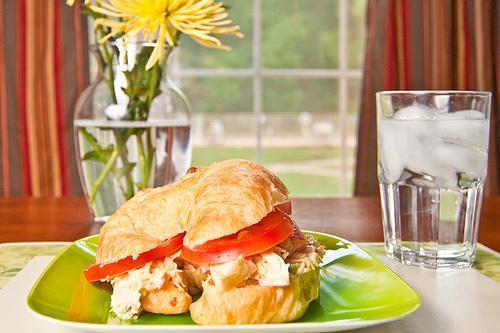How many glasses of water are on the table?
Give a very brief answer. 1. 